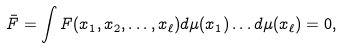Convert formula to latex. <formula><loc_0><loc_0><loc_500><loc_500>\bar { F } = \int F ( x _ { 1 } , x _ { 2 } , \dots , x _ { \ell } ) d \mu ( x _ { 1 } ) \dots d \mu ( x _ { \ell } ) = 0 ,</formula> 